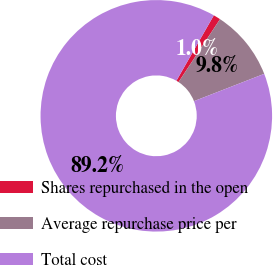Convert chart. <chart><loc_0><loc_0><loc_500><loc_500><pie_chart><fcel>Shares repurchased in the open<fcel>Average repurchase price per<fcel>Total cost<nl><fcel>1.0%<fcel>9.82%<fcel>89.19%<nl></chart> 